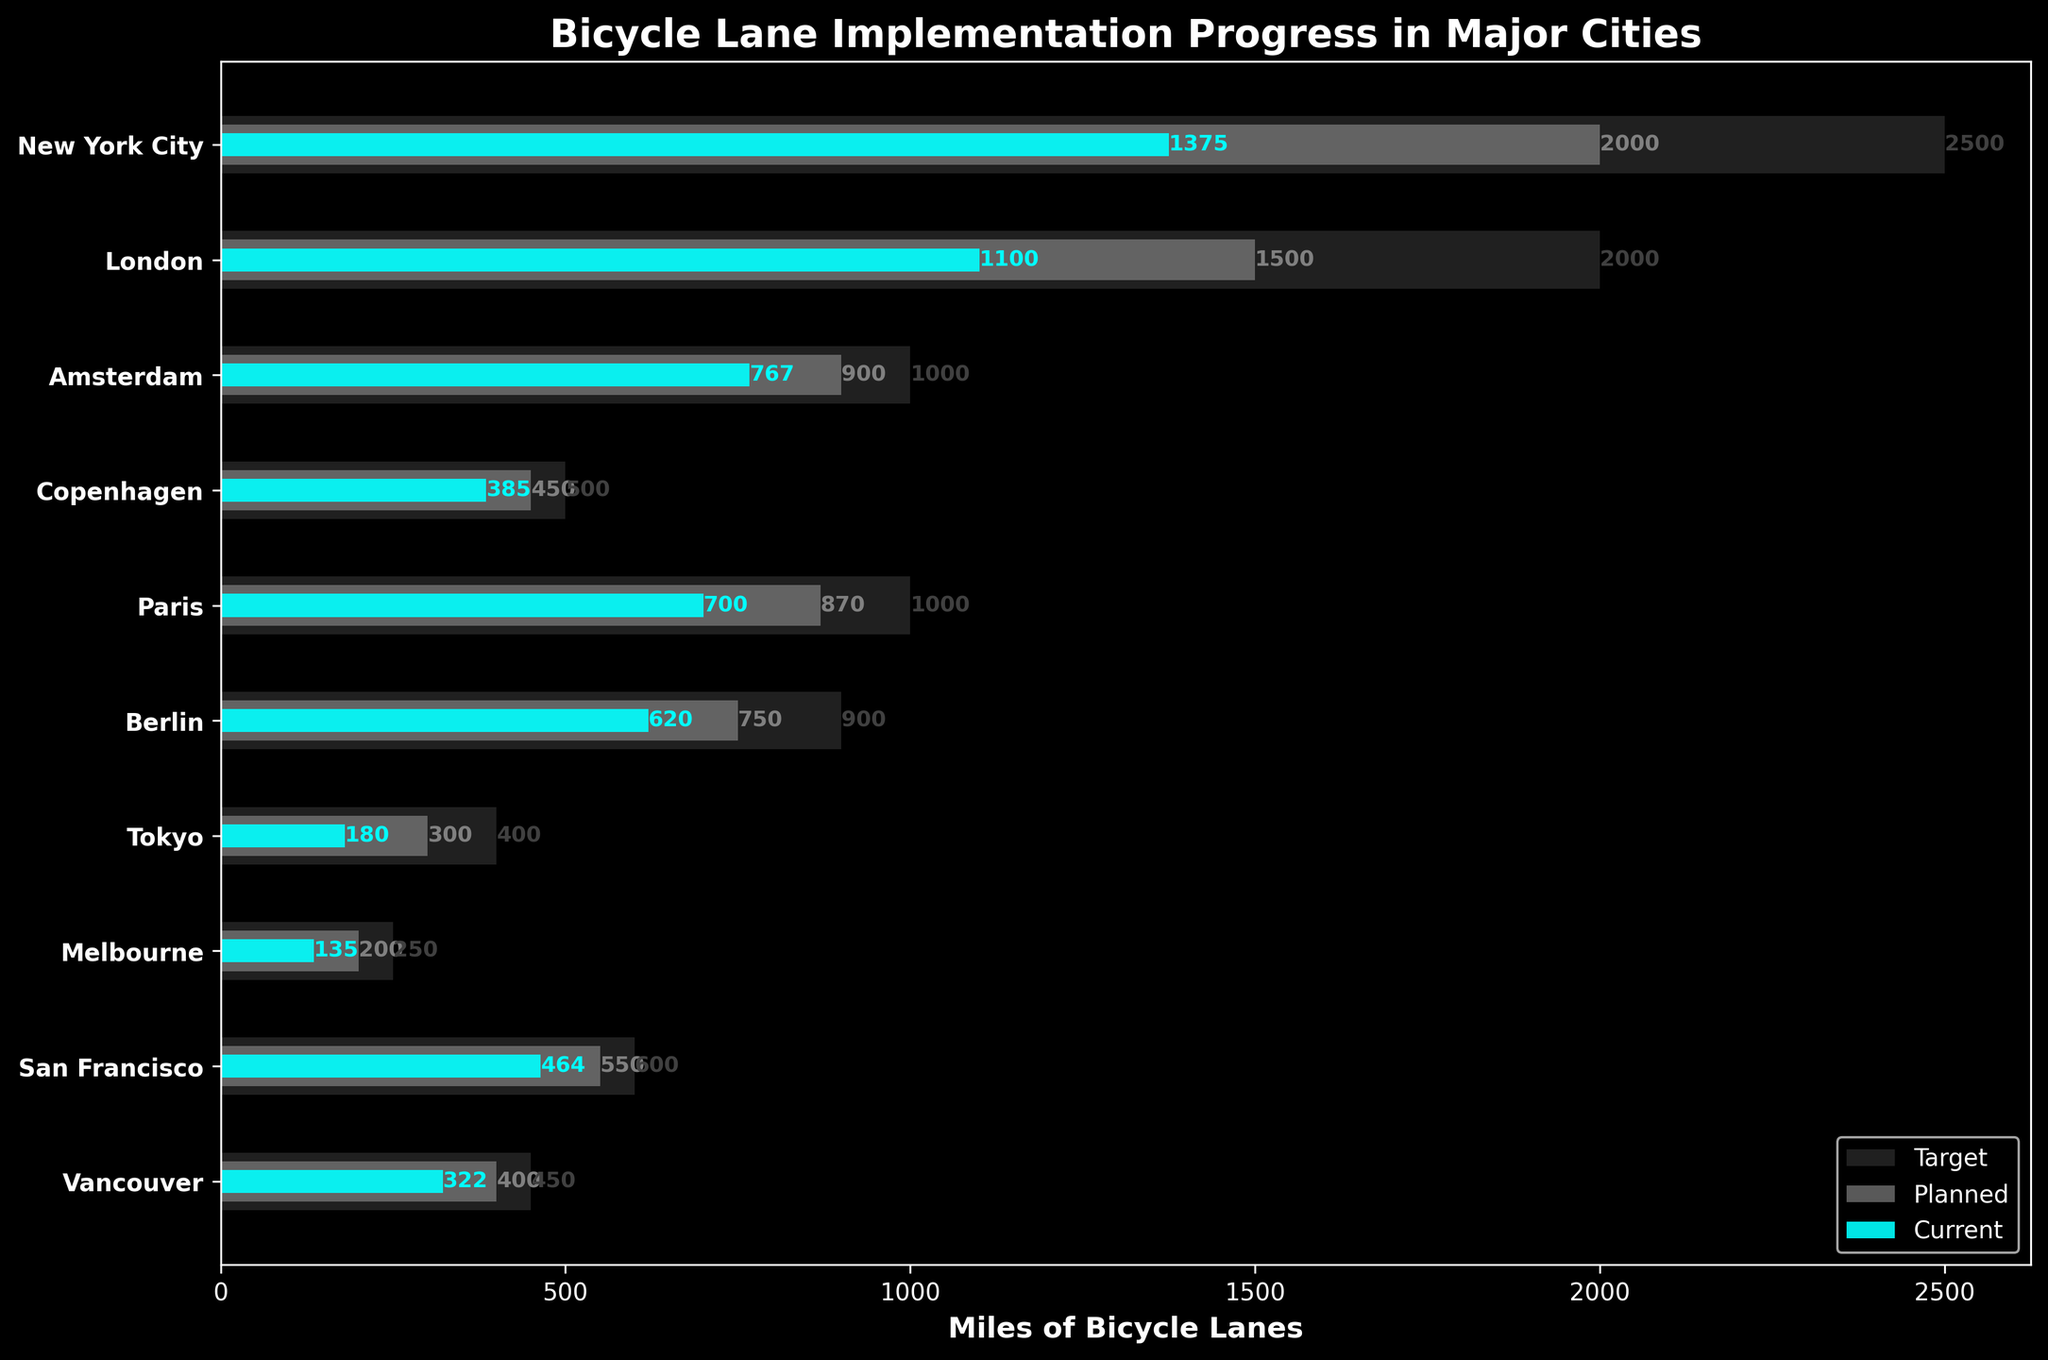What is the title of the figure? The title is displayed at the top of the figure. It reads "Bicycle Lane Implementation Progress in Major Cities".
Answer: Bicycle Lane Implementation Progress in Major Cities What do the three different bar colors represent in the bullet chart? The colors are explained by the legend at the bottom right: gray represents the target miles, dark gray represents the planned miles, and cyan represents the current miles of bicycle lanes.
Answer: The target miles, planned miles, and current miles, respectively Which city has the highest number of current miles of bicycle lanes? By looking at the cyan bars, we can see that New York City has the longest bar representing current miles.
Answer: New York City How many cities have a current mileage that exceeds 500 miles? From the cyan bars, New York City, London, Amsterdam, and San Francisco have current miles exceeding 500 miles.
Answer: 4 cities What is the difference between the planned miles and target miles for Paris? From the figure, Paris has 870 planned miles and 1000 target miles. The difference is 1000 - 870.
Answer: 130 miles What are the total target miles for all the cities combined? Sum the lengths of all gray bars: 2500 + 2000 + 1000 + 500 + 1000 + 900 + 400 + 250 + 600 + 450. The total is 10600 miles.
Answer: 10600 miles In which city is the difference between current miles and planned miles the smallest? Subtract the cyan bar lengths from the dark gray bar lengths for each city: New York City (625), London (400), Amsterdam (133), Copenhagen (65), Paris (170), Berlin (130), Tokyo (120), Melbourne (65), San Francisco (86), and Vancouver (78). Copenhagen has the smallest difference (65 miles).
Answer: Copenhagen Which city is closest to reaching its target miles? Compare the lengths of the bars for each city and see which one has the current miles closest to the target miles. Amsterdam is closest to its target with only 233 miles remaining.
Answer: Amsterdam What is the average planned bicycle lane miles for all the cities combined? Sum all planned miles and divide by the number of cities: (2000 + 1500 + 900 + 450 + 870 + 750 + 300 + 200 + 550 + 400) / 10 = 8920 / 10.
Answer: 892 miles How much more miles does Tokyo need to reach its target compared to current miles? Tokyo has 400 target miles and 180 current miles. 400 - 180 gives the needed miles to reach the target.
Answer: 220 miles 